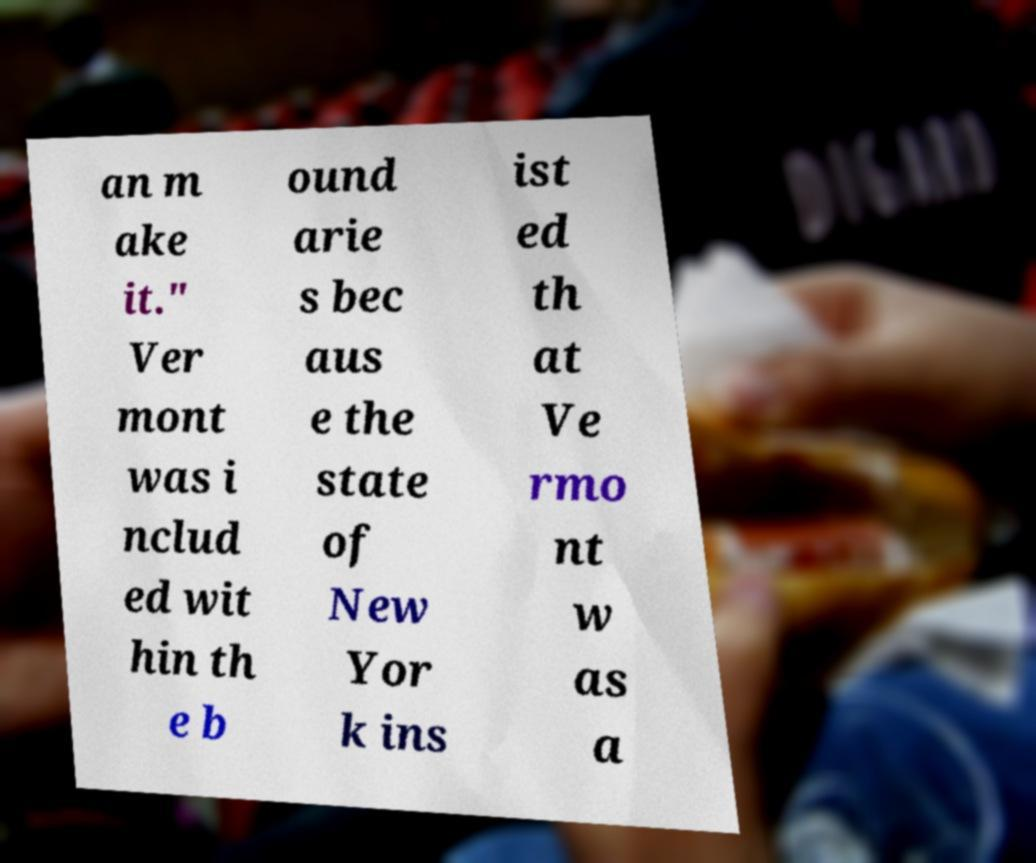Please identify and transcribe the text found in this image. an m ake it." Ver mont was i nclud ed wit hin th e b ound arie s bec aus e the state of New Yor k ins ist ed th at Ve rmo nt w as a 